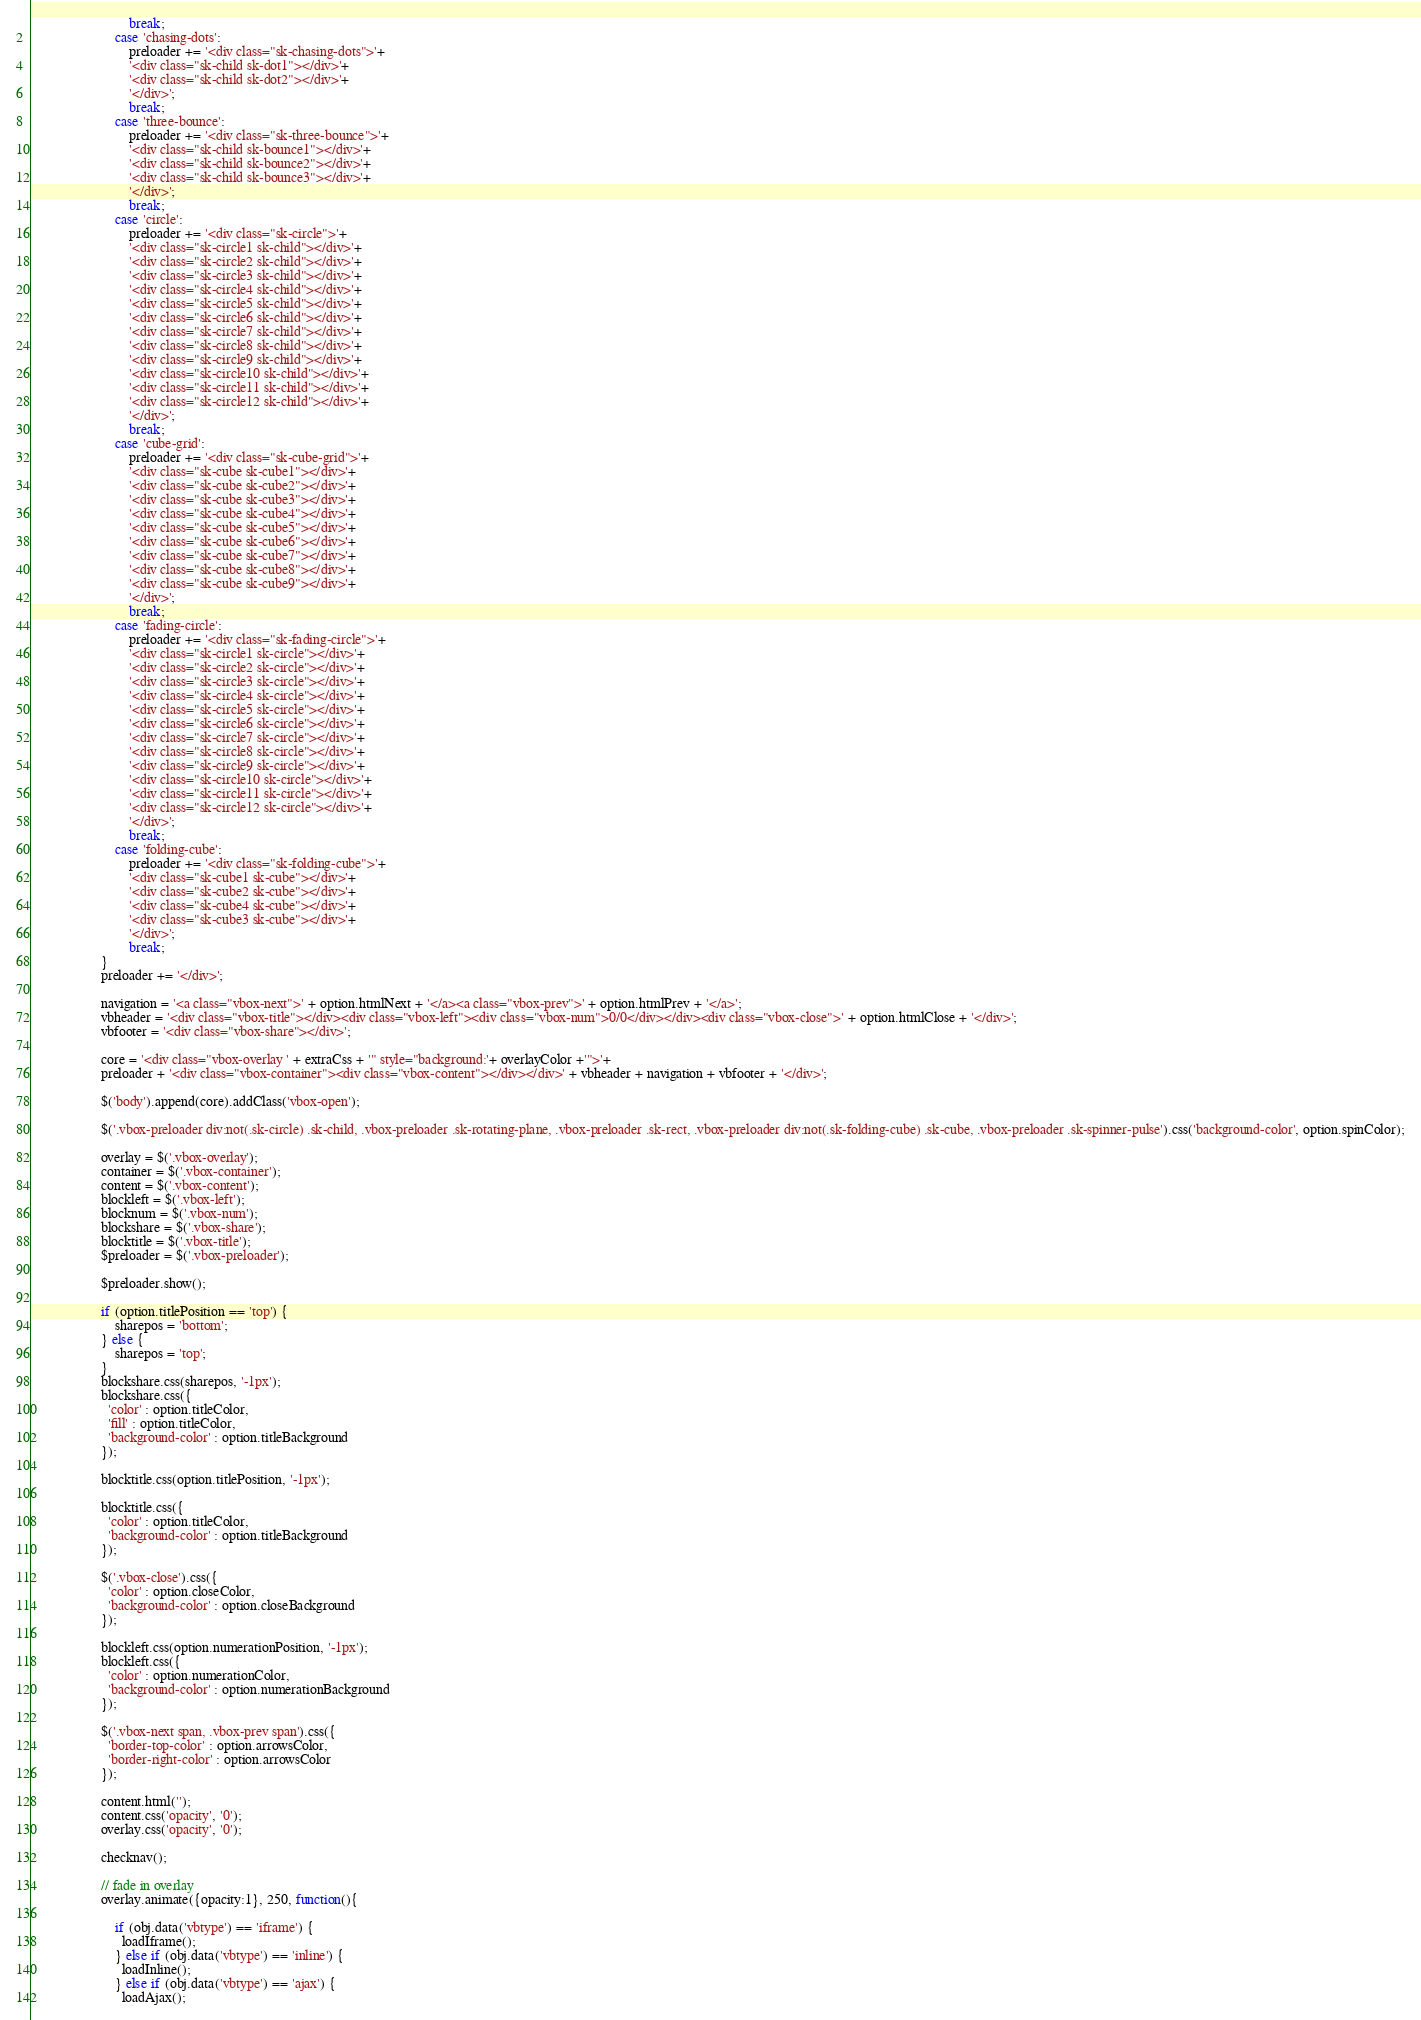<code> <loc_0><loc_0><loc_500><loc_500><_JavaScript_>                            break;
                        case 'chasing-dots':
                            preloader += '<div class="sk-chasing-dots">'+
                            '<div class="sk-child sk-dot1"></div>'+
                            '<div class="sk-child sk-dot2"></div>'+
                            '</div>';
                            break;
                        case 'three-bounce':
                            preloader += '<div class="sk-three-bounce">'+
                            '<div class="sk-child sk-bounce1"></div>'+
                            '<div class="sk-child sk-bounce2"></div>'+
                            '<div class="sk-child sk-bounce3"></div>'+
                            '</div>';
                            break;
                        case 'circle':
                            preloader += '<div class="sk-circle">'+
                            '<div class="sk-circle1 sk-child"></div>'+
                            '<div class="sk-circle2 sk-child"></div>'+
                            '<div class="sk-circle3 sk-child"></div>'+
                            '<div class="sk-circle4 sk-child"></div>'+
                            '<div class="sk-circle5 sk-child"></div>'+
                            '<div class="sk-circle6 sk-child"></div>'+
                            '<div class="sk-circle7 sk-child"></div>'+
                            '<div class="sk-circle8 sk-child"></div>'+
                            '<div class="sk-circle9 sk-child"></div>'+
                            '<div class="sk-circle10 sk-child"></div>'+
                            '<div class="sk-circle11 sk-child"></div>'+
                            '<div class="sk-circle12 sk-child"></div>'+
                            '</div>';
                            break;
                        case 'cube-grid':
                            preloader += '<div class="sk-cube-grid">'+
                            '<div class="sk-cube sk-cube1"></div>'+
                            '<div class="sk-cube sk-cube2"></div>'+
                            '<div class="sk-cube sk-cube3"></div>'+
                            '<div class="sk-cube sk-cube4"></div>'+
                            '<div class="sk-cube sk-cube5"></div>'+
                            '<div class="sk-cube sk-cube6"></div>'+
                            '<div class="sk-cube sk-cube7"></div>'+
                            '<div class="sk-cube sk-cube8"></div>'+
                            '<div class="sk-cube sk-cube9"></div>'+
                            '</div>';
                            break;
                        case 'fading-circle':
                            preloader += '<div class="sk-fading-circle">'+
                            '<div class="sk-circle1 sk-circle"></div>'+
                            '<div class="sk-circle2 sk-circle"></div>'+
                            '<div class="sk-circle3 sk-circle"></div>'+
                            '<div class="sk-circle4 sk-circle"></div>'+
                            '<div class="sk-circle5 sk-circle"></div>'+
                            '<div class="sk-circle6 sk-circle"></div>'+
                            '<div class="sk-circle7 sk-circle"></div>'+
                            '<div class="sk-circle8 sk-circle"></div>'+
                            '<div class="sk-circle9 sk-circle"></div>'+
                            '<div class="sk-circle10 sk-circle"></div>'+
                            '<div class="sk-circle11 sk-circle"></div>'+
                            '<div class="sk-circle12 sk-circle"></div>'+
                            '</div>';
                            break;
                        case 'folding-cube':
                            preloader += '<div class="sk-folding-cube">'+
                            '<div class="sk-cube1 sk-cube"></div>'+
                            '<div class="sk-cube2 sk-cube"></div>'+
                            '<div class="sk-cube4 sk-cube"></div>'+
                            '<div class="sk-cube3 sk-cube"></div>'+
                            '</div>';
                            break;
                    }
                    preloader += '</div>';

                    navigation = '<a class="vbox-next">' + option.htmlNext + '</a><a class="vbox-prev">' + option.htmlPrev + '</a>';
                    vbheader = '<div class="vbox-title"></div><div class="vbox-left"><div class="vbox-num">0/0</div></div><div class="vbox-close">' + option.htmlClose + '</div>';
                    vbfooter = '<div class="vbox-share"></div>';

                    core = '<div class="vbox-overlay ' + extraCss + '" style="background:'+ overlayColor +'">'+
                    preloader + '<div class="vbox-container"><div class="vbox-content"></div></div>' + vbheader + navigation + vbfooter + '</div>';

                    $('body').append(core).addClass('vbox-open');

                    $('.vbox-preloader div:not(.sk-circle) .sk-child, .vbox-preloader .sk-rotating-plane, .vbox-preloader .sk-rect, .vbox-preloader div:not(.sk-folding-cube) .sk-cube, .vbox-preloader .sk-spinner-pulse').css('background-color', option.spinColor);

                    overlay = $('.vbox-overlay');
                    container = $('.vbox-container');
                    content = $('.vbox-content');
                    blockleft = $('.vbox-left');
                    blocknum = $('.vbox-num');
                    blockshare = $('.vbox-share');
                    blocktitle = $('.vbox-title');
                    $preloader = $('.vbox-preloader');

                    $preloader.show();

                    if (option.titlePosition == 'top') {
                        sharepos = 'bottom';
                    } else {
                        sharepos = 'top';
                    }
                    blockshare.css(sharepos, '-1px');
                    blockshare.css({
                      'color' : option.titleColor,
                      'fill' : option.titleColor,
                      'background-color' : option.titleBackground
                    });

                    blocktitle.css(option.titlePosition, '-1px');

                    blocktitle.css({
                      'color' : option.titleColor,
                      'background-color' : option.titleBackground
                    });

                    $('.vbox-close').css({
                      'color' : option.closeColor,
                      'background-color' : option.closeBackground
                    });

                    blockleft.css(option.numerationPosition, '-1px');
                    blockleft.css({
                      'color' : option.numerationColor,
                      'background-color' : option.numerationBackground
                    });

                    $('.vbox-next span, .vbox-prev span').css({
                      'border-top-color' : option.arrowsColor,
                      'border-right-color' : option.arrowsColor
                    });

                    content.html('');
                    content.css('opacity', '0');
                    overlay.css('opacity', '0');

                    checknav();

                    // fade in overlay
                    overlay.animate({opacity:1}, 250, function(){

                        if (obj.data('vbtype') == 'iframe') {
                          loadIframe();
                        } else if (obj.data('vbtype') == 'inline') {
                          loadInline();
                        } else if (obj.data('vbtype') == 'ajax') {
                          loadAjax();</code> 